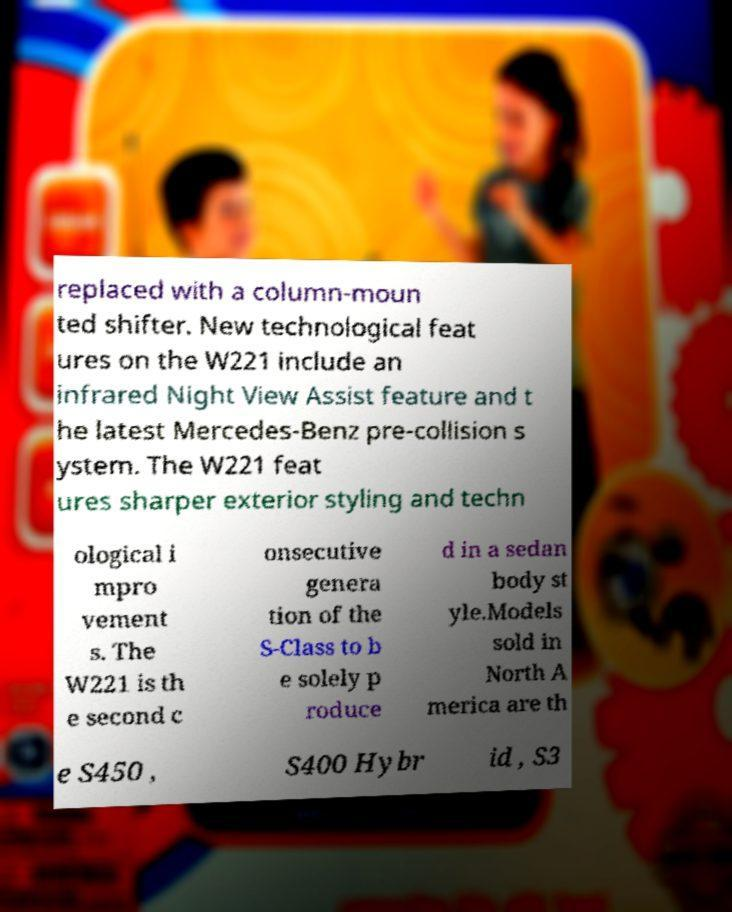What messages or text are displayed in this image? I need them in a readable, typed format. replaced with a column-moun ted shifter. New technological feat ures on the W221 include an infrared Night View Assist feature and t he latest Mercedes-Benz pre-collision s ystem. The W221 feat ures sharper exterior styling and techn ological i mpro vement s. The W221 is th e second c onsecutive genera tion of the S-Class to b e solely p roduce d in a sedan body st yle.Models sold in North A merica are th e S450 , S400 Hybr id , S3 